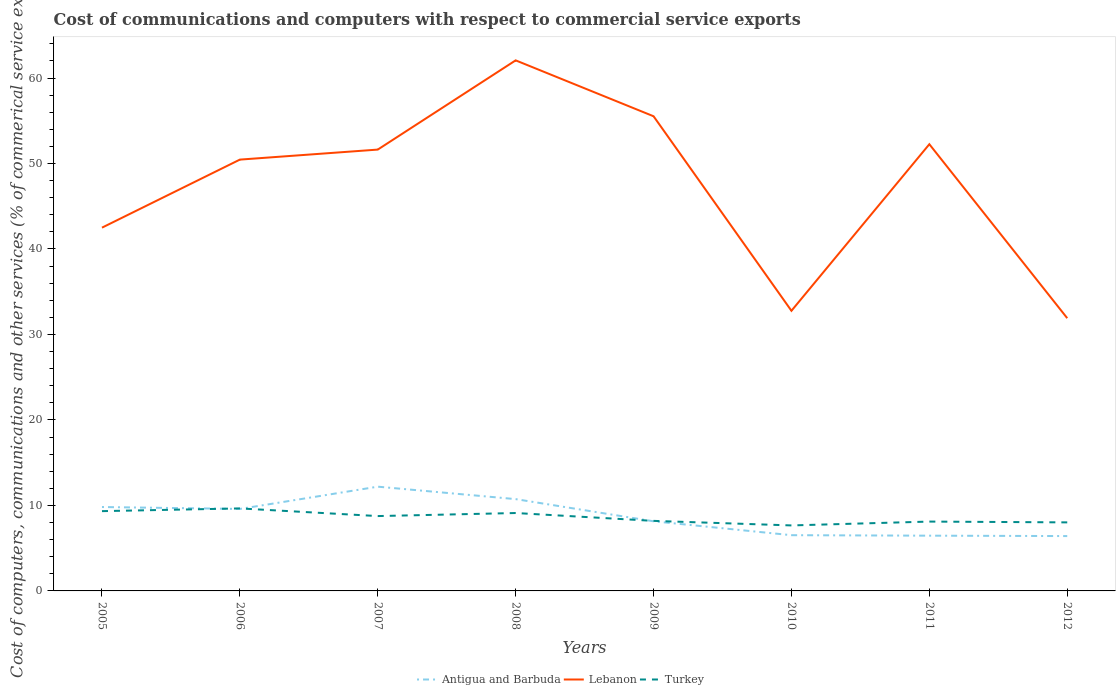How many different coloured lines are there?
Keep it short and to the point. 3. Across all years, what is the maximum cost of communications and computers in Antigua and Barbuda?
Ensure brevity in your answer.  6.42. In which year was the cost of communications and computers in Antigua and Barbuda maximum?
Offer a very short reply. 2012. What is the total cost of communications and computers in Antigua and Barbuda in the graph?
Your answer should be compact. 0.1. What is the difference between the highest and the second highest cost of communications and computers in Lebanon?
Keep it short and to the point. 30.16. Is the cost of communications and computers in Antigua and Barbuda strictly greater than the cost of communications and computers in Lebanon over the years?
Give a very brief answer. Yes. How many years are there in the graph?
Give a very brief answer. 8. Are the values on the major ticks of Y-axis written in scientific E-notation?
Offer a very short reply. No. Does the graph contain any zero values?
Offer a terse response. No. Does the graph contain grids?
Keep it short and to the point. No. How are the legend labels stacked?
Your response must be concise. Horizontal. What is the title of the graph?
Make the answer very short. Cost of communications and computers with respect to commercial service exports. Does "Seychelles" appear as one of the legend labels in the graph?
Offer a very short reply. No. What is the label or title of the X-axis?
Your answer should be very brief. Years. What is the label or title of the Y-axis?
Your answer should be very brief. Cost of computers, communications and other services (% of commerical service exports). What is the Cost of computers, communications and other services (% of commerical service exports) in Antigua and Barbuda in 2005?
Provide a succinct answer. 9.82. What is the Cost of computers, communications and other services (% of commerical service exports) in Lebanon in 2005?
Your answer should be very brief. 42.49. What is the Cost of computers, communications and other services (% of commerical service exports) in Turkey in 2005?
Provide a short and direct response. 9.33. What is the Cost of computers, communications and other services (% of commerical service exports) of Antigua and Barbuda in 2006?
Offer a very short reply. 9.59. What is the Cost of computers, communications and other services (% of commerical service exports) in Lebanon in 2006?
Offer a terse response. 50.46. What is the Cost of computers, communications and other services (% of commerical service exports) of Turkey in 2006?
Provide a short and direct response. 9.65. What is the Cost of computers, communications and other services (% of commerical service exports) in Antigua and Barbuda in 2007?
Keep it short and to the point. 12.2. What is the Cost of computers, communications and other services (% of commerical service exports) in Lebanon in 2007?
Keep it short and to the point. 51.63. What is the Cost of computers, communications and other services (% of commerical service exports) of Turkey in 2007?
Ensure brevity in your answer.  8.76. What is the Cost of computers, communications and other services (% of commerical service exports) of Antigua and Barbuda in 2008?
Your answer should be very brief. 10.74. What is the Cost of computers, communications and other services (% of commerical service exports) in Lebanon in 2008?
Offer a terse response. 62.07. What is the Cost of computers, communications and other services (% of commerical service exports) of Turkey in 2008?
Provide a succinct answer. 9.11. What is the Cost of computers, communications and other services (% of commerical service exports) in Antigua and Barbuda in 2009?
Offer a very short reply. 8.15. What is the Cost of computers, communications and other services (% of commerical service exports) in Lebanon in 2009?
Give a very brief answer. 55.53. What is the Cost of computers, communications and other services (% of commerical service exports) of Turkey in 2009?
Make the answer very short. 8.19. What is the Cost of computers, communications and other services (% of commerical service exports) in Antigua and Barbuda in 2010?
Provide a succinct answer. 6.52. What is the Cost of computers, communications and other services (% of commerical service exports) in Lebanon in 2010?
Offer a terse response. 32.77. What is the Cost of computers, communications and other services (% of commerical service exports) of Turkey in 2010?
Make the answer very short. 7.66. What is the Cost of computers, communications and other services (% of commerical service exports) in Antigua and Barbuda in 2011?
Provide a short and direct response. 6.46. What is the Cost of computers, communications and other services (% of commerical service exports) of Lebanon in 2011?
Ensure brevity in your answer.  52.26. What is the Cost of computers, communications and other services (% of commerical service exports) in Turkey in 2011?
Your response must be concise. 8.11. What is the Cost of computers, communications and other services (% of commerical service exports) of Antigua and Barbuda in 2012?
Offer a very short reply. 6.42. What is the Cost of computers, communications and other services (% of commerical service exports) of Lebanon in 2012?
Offer a terse response. 31.91. What is the Cost of computers, communications and other services (% of commerical service exports) of Turkey in 2012?
Your answer should be compact. 8.02. Across all years, what is the maximum Cost of computers, communications and other services (% of commerical service exports) of Antigua and Barbuda?
Your response must be concise. 12.2. Across all years, what is the maximum Cost of computers, communications and other services (% of commerical service exports) in Lebanon?
Offer a terse response. 62.07. Across all years, what is the maximum Cost of computers, communications and other services (% of commerical service exports) in Turkey?
Your response must be concise. 9.65. Across all years, what is the minimum Cost of computers, communications and other services (% of commerical service exports) of Antigua and Barbuda?
Provide a succinct answer. 6.42. Across all years, what is the minimum Cost of computers, communications and other services (% of commerical service exports) in Lebanon?
Your response must be concise. 31.91. Across all years, what is the minimum Cost of computers, communications and other services (% of commerical service exports) in Turkey?
Offer a terse response. 7.66. What is the total Cost of computers, communications and other services (% of commerical service exports) of Antigua and Barbuda in the graph?
Your response must be concise. 69.89. What is the total Cost of computers, communications and other services (% of commerical service exports) in Lebanon in the graph?
Your response must be concise. 379.11. What is the total Cost of computers, communications and other services (% of commerical service exports) in Turkey in the graph?
Provide a succinct answer. 68.84. What is the difference between the Cost of computers, communications and other services (% of commerical service exports) of Antigua and Barbuda in 2005 and that in 2006?
Provide a succinct answer. 0.23. What is the difference between the Cost of computers, communications and other services (% of commerical service exports) in Lebanon in 2005 and that in 2006?
Provide a succinct answer. -7.96. What is the difference between the Cost of computers, communications and other services (% of commerical service exports) in Turkey in 2005 and that in 2006?
Offer a terse response. -0.32. What is the difference between the Cost of computers, communications and other services (% of commerical service exports) in Antigua and Barbuda in 2005 and that in 2007?
Offer a very short reply. -2.38. What is the difference between the Cost of computers, communications and other services (% of commerical service exports) in Lebanon in 2005 and that in 2007?
Make the answer very short. -9.13. What is the difference between the Cost of computers, communications and other services (% of commerical service exports) of Turkey in 2005 and that in 2007?
Your answer should be compact. 0.58. What is the difference between the Cost of computers, communications and other services (% of commerical service exports) of Antigua and Barbuda in 2005 and that in 2008?
Provide a succinct answer. -0.92. What is the difference between the Cost of computers, communications and other services (% of commerical service exports) of Lebanon in 2005 and that in 2008?
Your answer should be compact. -19.57. What is the difference between the Cost of computers, communications and other services (% of commerical service exports) of Turkey in 2005 and that in 2008?
Make the answer very short. 0.22. What is the difference between the Cost of computers, communications and other services (% of commerical service exports) of Antigua and Barbuda in 2005 and that in 2009?
Your answer should be compact. 1.67. What is the difference between the Cost of computers, communications and other services (% of commerical service exports) of Lebanon in 2005 and that in 2009?
Offer a very short reply. -13.03. What is the difference between the Cost of computers, communications and other services (% of commerical service exports) in Turkey in 2005 and that in 2009?
Offer a very short reply. 1.14. What is the difference between the Cost of computers, communications and other services (% of commerical service exports) in Antigua and Barbuda in 2005 and that in 2010?
Your answer should be very brief. 3.29. What is the difference between the Cost of computers, communications and other services (% of commerical service exports) in Lebanon in 2005 and that in 2010?
Your answer should be compact. 9.72. What is the difference between the Cost of computers, communications and other services (% of commerical service exports) of Turkey in 2005 and that in 2010?
Offer a terse response. 1.67. What is the difference between the Cost of computers, communications and other services (% of commerical service exports) of Antigua and Barbuda in 2005 and that in 2011?
Provide a succinct answer. 3.35. What is the difference between the Cost of computers, communications and other services (% of commerical service exports) in Lebanon in 2005 and that in 2011?
Provide a short and direct response. -9.76. What is the difference between the Cost of computers, communications and other services (% of commerical service exports) in Turkey in 2005 and that in 2011?
Ensure brevity in your answer.  1.22. What is the difference between the Cost of computers, communications and other services (% of commerical service exports) of Antigua and Barbuda in 2005 and that in 2012?
Your answer should be very brief. 3.4. What is the difference between the Cost of computers, communications and other services (% of commerical service exports) of Lebanon in 2005 and that in 2012?
Your answer should be very brief. 10.59. What is the difference between the Cost of computers, communications and other services (% of commerical service exports) of Turkey in 2005 and that in 2012?
Offer a very short reply. 1.32. What is the difference between the Cost of computers, communications and other services (% of commerical service exports) of Antigua and Barbuda in 2006 and that in 2007?
Provide a short and direct response. -2.61. What is the difference between the Cost of computers, communications and other services (% of commerical service exports) in Lebanon in 2006 and that in 2007?
Provide a short and direct response. -1.17. What is the difference between the Cost of computers, communications and other services (% of commerical service exports) of Turkey in 2006 and that in 2007?
Provide a succinct answer. 0.9. What is the difference between the Cost of computers, communications and other services (% of commerical service exports) in Antigua and Barbuda in 2006 and that in 2008?
Ensure brevity in your answer.  -1.15. What is the difference between the Cost of computers, communications and other services (% of commerical service exports) of Lebanon in 2006 and that in 2008?
Your answer should be very brief. -11.61. What is the difference between the Cost of computers, communications and other services (% of commerical service exports) in Turkey in 2006 and that in 2008?
Keep it short and to the point. 0.54. What is the difference between the Cost of computers, communications and other services (% of commerical service exports) of Antigua and Barbuda in 2006 and that in 2009?
Ensure brevity in your answer.  1.44. What is the difference between the Cost of computers, communications and other services (% of commerical service exports) in Lebanon in 2006 and that in 2009?
Make the answer very short. -5.07. What is the difference between the Cost of computers, communications and other services (% of commerical service exports) of Turkey in 2006 and that in 2009?
Offer a very short reply. 1.46. What is the difference between the Cost of computers, communications and other services (% of commerical service exports) in Antigua and Barbuda in 2006 and that in 2010?
Give a very brief answer. 3.07. What is the difference between the Cost of computers, communications and other services (% of commerical service exports) in Lebanon in 2006 and that in 2010?
Keep it short and to the point. 17.68. What is the difference between the Cost of computers, communications and other services (% of commerical service exports) in Turkey in 2006 and that in 2010?
Provide a succinct answer. 1.99. What is the difference between the Cost of computers, communications and other services (% of commerical service exports) of Antigua and Barbuda in 2006 and that in 2011?
Your response must be concise. 3.13. What is the difference between the Cost of computers, communications and other services (% of commerical service exports) of Lebanon in 2006 and that in 2011?
Provide a succinct answer. -1.8. What is the difference between the Cost of computers, communications and other services (% of commerical service exports) in Turkey in 2006 and that in 2011?
Provide a succinct answer. 1.54. What is the difference between the Cost of computers, communications and other services (% of commerical service exports) of Antigua and Barbuda in 2006 and that in 2012?
Your response must be concise. 3.17. What is the difference between the Cost of computers, communications and other services (% of commerical service exports) of Lebanon in 2006 and that in 2012?
Give a very brief answer. 18.55. What is the difference between the Cost of computers, communications and other services (% of commerical service exports) of Turkey in 2006 and that in 2012?
Provide a short and direct response. 1.63. What is the difference between the Cost of computers, communications and other services (% of commerical service exports) in Antigua and Barbuda in 2007 and that in 2008?
Offer a terse response. 1.46. What is the difference between the Cost of computers, communications and other services (% of commerical service exports) of Lebanon in 2007 and that in 2008?
Offer a very short reply. -10.44. What is the difference between the Cost of computers, communications and other services (% of commerical service exports) of Turkey in 2007 and that in 2008?
Your response must be concise. -0.36. What is the difference between the Cost of computers, communications and other services (% of commerical service exports) of Antigua and Barbuda in 2007 and that in 2009?
Give a very brief answer. 4.05. What is the difference between the Cost of computers, communications and other services (% of commerical service exports) in Lebanon in 2007 and that in 2009?
Give a very brief answer. -3.9. What is the difference between the Cost of computers, communications and other services (% of commerical service exports) of Turkey in 2007 and that in 2009?
Keep it short and to the point. 0.56. What is the difference between the Cost of computers, communications and other services (% of commerical service exports) of Antigua and Barbuda in 2007 and that in 2010?
Offer a very short reply. 5.68. What is the difference between the Cost of computers, communications and other services (% of commerical service exports) in Lebanon in 2007 and that in 2010?
Your answer should be compact. 18.86. What is the difference between the Cost of computers, communications and other services (% of commerical service exports) of Turkey in 2007 and that in 2010?
Keep it short and to the point. 1.09. What is the difference between the Cost of computers, communications and other services (% of commerical service exports) in Antigua and Barbuda in 2007 and that in 2011?
Ensure brevity in your answer.  5.73. What is the difference between the Cost of computers, communications and other services (% of commerical service exports) in Lebanon in 2007 and that in 2011?
Your answer should be compact. -0.63. What is the difference between the Cost of computers, communications and other services (% of commerical service exports) in Turkey in 2007 and that in 2011?
Provide a succinct answer. 0.64. What is the difference between the Cost of computers, communications and other services (% of commerical service exports) of Antigua and Barbuda in 2007 and that in 2012?
Provide a succinct answer. 5.78. What is the difference between the Cost of computers, communications and other services (% of commerical service exports) in Lebanon in 2007 and that in 2012?
Give a very brief answer. 19.72. What is the difference between the Cost of computers, communications and other services (% of commerical service exports) of Turkey in 2007 and that in 2012?
Offer a terse response. 0.74. What is the difference between the Cost of computers, communications and other services (% of commerical service exports) in Antigua and Barbuda in 2008 and that in 2009?
Offer a very short reply. 2.59. What is the difference between the Cost of computers, communications and other services (% of commerical service exports) of Lebanon in 2008 and that in 2009?
Keep it short and to the point. 6.54. What is the difference between the Cost of computers, communications and other services (% of commerical service exports) in Turkey in 2008 and that in 2009?
Offer a terse response. 0.92. What is the difference between the Cost of computers, communications and other services (% of commerical service exports) in Antigua and Barbuda in 2008 and that in 2010?
Offer a terse response. 4.22. What is the difference between the Cost of computers, communications and other services (% of commerical service exports) in Lebanon in 2008 and that in 2010?
Provide a succinct answer. 29.29. What is the difference between the Cost of computers, communications and other services (% of commerical service exports) in Turkey in 2008 and that in 2010?
Keep it short and to the point. 1.45. What is the difference between the Cost of computers, communications and other services (% of commerical service exports) of Antigua and Barbuda in 2008 and that in 2011?
Give a very brief answer. 4.28. What is the difference between the Cost of computers, communications and other services (% of commerical service exports) in Lebanon in 2008 and that in 2011?
Your answer should be compact. 9.81. What is the difference between the Cost of computers, communications and other services (% of commerical service exports) of Turkey in 2008 and that in 2011?
Keep it short and to the point. 1. What is the difference between the Cost of computers, communications and other services (% of commerical service exports) in Antigua and Barbuda in 2008 and that in 2012?
Your answer should be very brief. 4.32. What is the difference between the Cost of computers, communications and other services (% of commerical service exports) in Lebanon in 2008 and that in 2012?
Provide a succinct answer. 30.16. What is the difference between the Cost of computers, communications and other services (% of commerical service exports) of Turkey in 2008 and that in 2012?
Make the answer very short. 1.1. What is the difference between the Cost of computers, communications and other services (% of commerical service exports) in Antigua and Barbuda in 2009 and that in 2010?
Your response must be concise. 1.63. What is the difference between the Cost of computers, communications and other services (% of commerical service exports) of Lebanon in 2009 and that in 2010?
Provide a short and direct response. 22.76. What is the difference between the Cost of computers, communications and other services (% of commerical service exports) in Turkey in 2009 and that in 2010?
Make the answer very short. 0.53. What is the difference between the Cost of computers, communications and other services (% of commerical service exports) in Antigua and Barbuda in 2009 and that in 2011?
Offer a very short reply. 1.68. What is the difference between the Cost of computers, communications and other services (% of commerical service exports) of Lebanon in 2009 and that in 2011?
Provide a short and direct response. 3.27. What is the difference between the Cost of computers, communications and other services (% of commerical service exports) of Turkey in 2009 and that in 2011?
Offer a terse response. 0.08. What is the difference between the Cost of computers, communications and other services (% of commerical service exports) in Antigua and Barbuda in 2009 and that in 2012?
Provide a succinct answer. 1.73. What is the difference between the Cost of computers, communications and other services (% of commerical service exports) in Lebanon in 2009 and that in 2012?
Ensure brevity in your answer.  23.62. What is the difference between the Cost of computers, communications and other services (% of commerical service exports) in Turkey in 2009 and that in 2012?
Make the answer very short. 0.18. What is the difference between the Cost of computers, communications and other services (% of commerical service exports) of Antigua and Barbuda in 2010 and that in 2011?
Your response must be concise. 0.06. What is the difference between the Cost of computers, communications and other services (% of commerical service exports) in Lebanon in 2010 and that in 2011?
Offer a very short reply. -19.48. What is the difference between the Cost of computers, communications and other services (% of commerical service exports) in Turkey in 2010 and that in 2011?
Your response must be concise. -0.45. What is the difference between the Cost of computers, communications and other services (% of commerical service exports) in Antigua and Barbuda in 2010 and that in 2012?
Your answer should be very brief. 0.1. What is the difference between the Cost of computers, communications and other services (% of commerical service exports) of Lebanon in 2010 and that in 2012?
Give a very brief answer. 0.87. What is the difference between the Cost of computers, communications and other services (% of commerical service exports) of Turkey in 2010 and that in 2012?
Give a very brief answer. -0.36. What is the difference between the Cost of computers, communications and other services (% of commerical service exports) in Antigua and Barbuda in 2011 and that in 2012?
Your response must be concise. 0.05. What is the difference between the Cost of computers, communications and other services (% of commerical service exports) in Lebanon in 2011 and that in 2012?
Offer a terse response. 20.35. What is the difference between the Cost of computers, communications and other services (% of commerical service exports) in Turkey in 2011 and that in 2012?
Your response must be concise. 0.09. What is the difference between the Cost of computers, communications and other services (% of commerical service exports) in Antigua and Barbuda in 2005 and the Cost of computers, communications and other services (% of commerical service exports) in Lebanon in 2006?
Offer a terse response. -40.64. What is the difference between the Cost of computers, communications and other services (% of commerical service exports) in Antigua and Barbuda in 2005 and the Cost of computers, communications and other services (% of commerical service exports) in Turkey in 2006?
Ensure brevity in your answer.  0.16. What is the difference between the Cost of computers, communications and other services (% of commerical service exports) of Lebanon in 2005 and the Cost of computers, communications and other services (% of commerical service exports) of Turkey in 2006?
Your answer should be very brief. 32.84. What is the difference between the Cost of computers, communications and other services (% of commerical service exports) of Antigua and Barbuda in 2005 and the Cost of computers, communications and other services (% of commerical service exports) of Lebanon in 2007?
Keep it short and to the point. -41.81. What is the difference between the Cost of computers, communications and other services (% of commerical service exports) of Antigua and Barbuda in 2005 and the Cost of computers, communications and other services (% of commerical service exports) of Turkey in 2007?
Keep it short and to the point. 1.06. What is the difference between the Cost of computers, communications and other services (% of commerical service exports) of Lebanon in 2005 and the Cost of computers, communications and other services (% of commerical service exports) of Turkey in 2007?
Offer a terse response. 33.74. What is the difference between the Cost of computers, communications and other services (% of commerical service exports) in Antigua and Barbuda in 2005 and the Cost of computers, communications and other services (% of commerical service exports) in Lebanon in 2008?
Offer a terse response. -52.25. What is the difference between the Cost of computers, communications and other services (% of commerical service exports) of Antigua and Barbuda in 2005 and the Cost of computers, communications and other services (% of commerical service exports) of Turkey in 2008?
Ensure brevity in your answer.  0.7. What is the difference between the Cost of computers, communications and other services (% of commerical service exports) in Lebanon in 2005 and the Cost of computers, communications and other services (% of commerical service exports) in Turkey in 2008?
Make the answer very short. 33.38. What is the difference between the Cost of computers, communications and other services (% of commerical service exports) in Antigua and Barbuda in 2005 and the Cost of computers, communications and other services (% of commerical service exports) in Lebanon in 2009?
Provide a short and direct response. -45.71. What is the difference between the Cost of computers, communications and other services (% of commerical service exports) of Antigua and Barbuda in 2005 and the Cost of computers, communications and other services (% of commerical service exports) of Turkey in 2009?
Your response must be concise. 1.62. What is the difference between the Cost of computers, communications and other services (% of commerical service exports) in Lebanon in 2005 and the Cost of computers, communications and other services (% of commerical service exports) in Turkey in 2009?
Your answer should be very brief. 34.3. What is the difference between the Cost of computers, communications and other services (% of commerical service exports) in Antigua and Barbuda in 2005 and the Cost of computers, communications and other services (% of commerical service exports) in Lebanon in 2010?
Keep it short and to the point. -22.96. What is the difference between the Cost of computers, communications and other services (% of commerical service exports) in Antigua and Barbuda in 2005 and the Cost of computers, communications and other services (% of commerical service exports) in Turkey in 2010?
Provide a succinct answer. 2.15. What is the difference between the Cost of computers, communications and other services (% of commerical service exports) in Lebanon in 2005 and the Cost of computers, communications and other services (% of commerical service exports) in Turkey in 2010?
Make the answer very short. 34.83. What is the difference between the Cost of computers, communications and other services (% of commerical service exports) in Antigua and Barbuda in 2005 and the Cost of computers, communications and other services (% of commerical service exports) in Lebanon in 2011?
Provide a short and direct response. -42.44. What is the difference between the Cost of computers, communications and other services (% of commerical service exports) of Antigua and Barbuda in 2005 and the Cost of computers, communications and other services (% of commerical service exports) of Turkey in 2011?
Offer a very short reply. 1.7. What is the difference between the Cost of computers, communications and other services (% of commerical service exports) of Lebanon in 2005 and the Cost of computers, communications and other services (% of commerical service exports) of Turkey in 2011?
Provide a short and direct response. 34.38. What is the difference between the Cost of computers, communications and other services (% of commerical service exports) in Antigua and Barbuda in 2005 and the Cost of computers, communications and other services (% of commerical service exports) in Lebanon in 2012?
Make the answer very short. -22.09. What is the difference between the Cost of computers, communications and other services (% of commerical service exports) of Antigua and Barbuda in 2005 and the Cost of computers, communications and other services (% of commerical service exports) of Turkey in 2012?
Provide a short and direct response. 1.8. What is the difference between the Cost of computers, communications and other services (% of commerical service exports) of Lebanon in 2005 and the Cost of computers, communications and other services (% of commerical service exports) of Turkey in 2012?
Offer a very short reply. 34.48. What is the difference between the Cost of computers, communications and other services (% of commerical service exports) in Antigua and Barbuda in 2006 and the Cost of computers, communications and other services (% of commerical service exports) in Lebanon in 2007?
Provide a succinct answer. -42.04. What is the difference between the Cost of computers, communications and other services (% of commerical service exports) in Antigua and Barbuda in 2006 and the Cost of computers, communications and other services (% of commerical service exports) in Turkey in 2007?
Keep it short and to the point. 0.83. What is the difference between the Cost of computers, communications and other services (% of commerical service exports) of Lebanon in 2006 and the Cost of computers, communications and other services (% of commerical service exports) of Turkey in 2007?
Offer a terse response. 41.7. What is the difference between the Cost of computers, communications and other services (% of commerical service exports) in Antigua and Barbuda in 2006 and the Cost of computers, communications and other services (% of commerical service exports) in Lebanon in 2008?
Provide a short and direct response. -52.48. What is the difference between the Cost of computers, communications and other services (% of commerical service exports) in Antigua and Barbuda in 2006 and the Cost of computers, communications and other services (% of commerical service exports) in Turkey in 2008?
Offer a very short reply. 0.48. What is the difference between the Cost of computers, communications and other services (% of commerical service exports) of Lebanon in 2006 and the Cost of computers, communications and other services (% of commerical service exports) of Turkey in 2008?
Provide a short and direct response. 41.34. What is the difference between the Cost of computers, communications and other services (% of commerical service exports) in Antigua and Barbuda in 2006 and the Cost of computers, communications and other services (% of commerical service exports) in Lebanon in 2009?
Make the answer very short. -45.94. What is the difference between the Cost of computers, communications and other services (% of commerical service exports) in Antigua and Barbuda in 2006 and the Cost of computers, communications and other services (% of commerical service exports) in Turkey in 2009?
Your response must be concise. 1.4. What is the difference between the Cost of computers, communications and other services (% of commerical service exports) in Lebanon in 2006 and the Cost of computers, communications and other services (% of commerical service exports) in Turkey in 2009?
Provide a succinct answer. 42.26. What is the difference between the Cost of computers, communications and other services (% of commerical service exports) in Antigua and Barbuda in 2006 and the Cost of computers, communications and other services (% of commerical service exports) in Lebanon in 2010?
Your answer should be compact. -23.18. What is the difference between the Cost of computers, communications and other services (% of commerical service exports) of Antigua and Barbuda in 2006 and the Cost of computers, communications and other services (% of commerical service exports) of Turkey in 2010?
Your answer should be compact. 1.93. What is the difference between the Cost of computers, communications and other services (% of commerical service exports) in Lebanon in 2006 and the Cost of computers, communications and other services (% of commerical service exports) in Turkey in 2010?
Your answer should be compact. 42.79. What is the difference between the Cost of computers, communications and other services (% of commerical service exports) of Antigua and Barbuda in 2006 and the Cost of computers, communications and other services (% of commerical service exports) of Lebanon in 2011?
Offer a very short reply. -42.67. What is the difference between the Cost of computers, communications and other services (% of commerical service exports) in Antigua and Barbuda in 2006 and the Cost of computers, communications and other services (% of commerical service exports) in Turkey in 2011?
Make the answer very short. 1.48. What is the difference between the Cost of computers, communications and other services (% of commerical service exports) in Lebanon in 2006 and the Cost of computers, communications and other services (% of commerical service exports) in Turkey in 2011?
Make the answer very short. 42.34. What is the difference between the Cost of computers, communications and other services (% of commerical service exports) in Antigua and Barbuda in 2006 and the Cost of computers, communications and other services (% of commerical service exports) in Lebanon in 2012?
Provide a short and direct response. -22.32. What is the difference between the Cost of computers, communications and other services (% of commerical service exports) in Antigua and Barbuda in 2006 and the Cost of computers, communications and other services (% of commerical service exports) in Turkey in 2012?
Provide a short and direct response. 1.57. What is the difference between the Cost of computers, communications and other services (% of commerical service exports) in Lebanon in 2006 and the Cost of computers, communications and other services (% of commerical service exports) in Turkey in 2012?
Offer a very short reply. 42.44. What is the difference between the Cost of computers, communications and other services (% of commerical service exports) in Antigua and Barbuda in 2007 and the Cost of computers, communications and other services (% of commerical service exports) in Lebanon in 2008?
Offer a very short reply. -49.87. What is the difference between the Cost of computers, communications and other services (% of commerical service exports) of Antigua and Barbuda in 2007 and the Cost of computers, communications and other services (% of commerical service exports) of Turkey in 2008?
Give a very brief answer. 3.08. What is the difference between the Cost of computers, communications and other services (% of commerical service exports) of Lebanon in 2007 and the Cost of computers, communications and other services (% of commerical service exports) of Turkey in 2008?
Ensure brevity in your answer.  42.52. What is the difference between the Cost of computers, communications and other services (% of commerical service exports) of Antigua and Barbuda in 2007 and the Cost of computers, communications and other services (% of commerical service exports) of Lebanon in 2009?
Give a very brief answer. -43.33. What is the difference between the Cost of computers, communications and other services (% of commerical service exports) of Antigua and Barbuda in 2007 and the Cost of computers, communications and other services (% of commerical service exports) of Turkey in 2009?
Your answer should be very brief. 4. What is the difference between the Cost of computers, communications and other services (% of commerical service exports) in Lebanon in 2007 and the Cost of computers, communications and other services (% of commerical service exports) in Turkey in 2009?
Your answer should be very brief. 43.44. What is the difference between the Cost of computers, communications and other services (% of commerical service exports) of Antigua and Barbuda in 2007 and the Cost of computers, communications and other services (% of commerical service exports) of Lebanon in 2010?
Your answer should be compact. -20.58. What is the difference between the Cost of computers, communications and other services (% of commerical service exports) in Antigua and Barbuda in 2007 and the Cost of computers, communications and other services (% of commerical service exports) in Turkey in 2010?
Provide a succinct answer. 4.53. What is the difference between the Cost of computers, communications and other services (% of commerical service exports) in Lebanon in 2007 and the Cost of computers, communications and other services (% of commerical service exports) in Turkey in 2010?
Your answer should be very brief. 43.97. What is the difference between the Cost of computers, communications and other services (% of commerical service exports) in Antigua and Barbuda in 2007 and the Cost of computers, communications and other services (% of commerical service exports) in Lebanon in 2011?
Make the answer very short. -40.06. What is the difference between the Cost of computers, communications and other services (% of commerical service exports) in Antigua and Barbuda in 2007 and the Cost of computers, communications and other services (% of commerical service exports) in Turkey in 2011?
Your answer should be compact. 4.08. What is the difference between the Cost of computers, communications and other services (% of commerical service exports) in Lebanon in 2007 and the Cost of computers, communications and other services (% of commerical service exports) in Turkey in 2011?
Ensure brevity in your answer.  43.52. What is the difference between the Cost of computers, communications and other services (% of commerical service exports) in Antigua and Barbuda in 2007 and the Cost of computers, communications and other services (% of commerical service exports) in Lebanon in 2012?
Offer a very short reply. -19.71. What is the difference between the Cost of computers, communications and other services (% of commerical service exports) in Antigua and Barbuda in 2007 and the Cost of computers, communications and other services (% of commerical service exports) in Turkey in 2012?
Give a very brief answer. 4.18. What is the difference between the Cost of computers, communications and other services (% of commerical service exports) in Lebanon in 2007 and the Cost of computers, communications and other services (% of commerical service exports) in Turkey in 2012?
Offer a very short reply. 43.61. What is the difference between the Cost of computers, communications and other services (% of commerical service exports) in Antigua and Barbuda in 2008 and the Cost of computers, communications and other services (% of commerical service exports) in Lebanon in 2009?
Your answer should be compact. -44.79. What is the difference between the Cost of computers, communications and other services (% of commerical service exports) of Antigua and Barbuda in 2008 and the Cost of computers, communications and other services (% of commerical service exports) of Turkey in 2009?
Give a very brief answer. 2.55. What is the difference between the Cost of computers, communications and other services (% of commerical service exports) of Lebanon in 2008 and the Cost of computers, communications and other services (% of commerical service exports) of Turkey in 2009?
Your answer should be compact. 53.87. What is the difference between the Cost of computers, communications and other services (% of commerical service exports) of Antigua and Barbuda in 2008 and the Cost of computers, communications and other services (% of commerical service exports) of Lebanon in 2010?
Your answer should be compact. -22.03. What is the difference between the Cost of computers, communications and other services (% of commerical service exports) in Antigua and Barbuda in 2008 and the Cost of computers, communications and other services (% of commerical service exports) in Turkey in 2010?
Your answer should be compact. 3.08. What is the difference between the Cost of computers, communications and other services (% of commerical service exports) of Lebanon in 2008 and the Cost of computers, communications and other services (% of commerical service exports) of Turkey in 2010?
Ensure brevity in your answer.  54.41. What is the difference between the Cost of computers, communications and other services (% of commerical service exports) in Antigua and Barbuda in 2008 and the Cost of computers, communications and other services (% of commerical service exports) in Lebanon in 2011?
Give a very brief answer. -41.52. What is the difference between the Cost of computers, communications and other services (% of commerical service exports) of Antigua and Barbuda in 2008 and the Cost of computers, communications and other services (% of commerical service exports) of Turkey in 2011?
Provide a short and direct response. 2.63. What is the difference between the Cost of computers, communications and other services (% of commerical service exports) of Lebanon in 2008 and the Cost of computers, communications and other services (% of commerical service exports) of Turkey in 2011?
Provide a succinct answer. 53.96. What is the difference between the Cost of computers, communications and other services (% of commerical service exports) of Antigua and Barbuda in 2008 and the Cost of computers, communications and other services (% of commerical service exports) of Lebanon in 2012?
Provide a short and direct response. -21.17. What is the difference between the Cost of computers, communications and other services (% of commerical service exports) of Antigua and Barbuda in 2008 and the Cost of computers, communications and other services (% of commerical service exports) of Turkey in 2012?
Make the answer very short. 2.72. What is the difference between the Cost of computers, communications and other services (% of commerical service exports) in Lebanon in 2008 and the Cost of computers, communications and other services (% of commerical service exports) in Turkey in 2012?
Provide a succinct answer. 54.05. What is the difference between the Cost of computers, communications and other services (% of commerical service exports) of Antigua and Barbuda in 2009 and the Cost of computers, communications and other services (% of commerical service exports) of Lebanon in 2010?
Ensure brevity in your answer.  -24.63. What is the difference between the Cost of computers, communications and other services (% of commerical service exports) of Antigua and Barbuda in 2009 and the Cost of computers, communications and other services (% of commerical service exports) of Turkey in 2010?
Keep it short and to the point. 0.48. What is the difference between the Cost of computers, communications and other services (% of commerical service exports) in Lebanon in 2009 and the Cost of computers, communications and other services (% of commerical service exports) in Turkey in 2010?
Ensure brevity in your answer.  47.87. What is the difference between the Cost of computers, communications and other services (% of commerical service exports) of Antigua and Barbuda in 2009 and the Cost of computers, communications and other services (% of commerical service exports) of Lebanon in 2011?
Make the answer very short. -44.11. What is the difference between the Cost of computers, communications and other services (% of commerical service exports) of Antigua and Barbuda in 2009 and the Cost of computers, communications and other services (% of commerical service exports) of Turkey in 2011?
Provide a succinct answer. 0.03. What is the difference between the Cost of computers, communications and other services (% of commerical service exports) in Lebanon in 2009 and the Cost of computers, communications and other services (% of commerical service exports) in Turkey in 2011?
Your response must be concise. 47.42. What is the difference between the Cost of computers, communications and other services (% of commerical service exports) in Antigua and Barbuda in 2009 and the Cost of computers, communications and other services (% of commerical service exports) in Lebanon in 2012?
Make the answer very short. -23.76. What is the difference between the Cost of computers, communications and other services (% of commerical service exports) in Antigua and Barbuda in 2009 and the Cost of computers, communications and other services (% of commerical service exports) in Turkey in 2012?
Your response must be concise. 0.13. What is the difference between the Cost of computers, communications and other services (% of commerical service exports) of Lebanon in 2009 and the Cost of computers, communications and other services (% of commerical service exports) of Turkey in 2012?
Offer a terse response. 47.51. What is the difference between the Cost of computers, communications and other services (% of commerical service exports) of Antigua and Barbuda in 2010 and the Cost of computers, communications and other services (% of commerical service exports) of Lebanon in 2011?
Ensure brevity in your answer.  -45.74. What is the difference between the Cost of computers, communications and other services (% of commerical service exports) in Antigua and Barbuda in 2010 and the Cost of computers, communications and other services (% of commerical service exports) in Turkey in 2011?
Provide a succinct answer. -1.59. What is the difference between the Cost of computers, communications and other services (% of commerical service exports) in Lebanon in 2010 and the Cost of computers, communications and other services (% of commerical service exports) in Turkey in 2011?
Provide a succinct answer. 24.66. What is the difference between the Cost of computers, communications and other services (% of commerical service exports) of Antigua and Barbuda in 2010 and the Cost of computers, communications and other services (% of commerical service exports) of Lebanon in 2012?
Provide a short and direct response. -25.39. What is the difference between the Cost of computers, communications and other services (% of commerical service exports) of Antigua and Barbuda in 2010 and the Cost of computers, communications and other services (% of commerical service exports) of Turkey in 2012?
Make the answer very short. -1.5. What is the difference between the Cost of computers, communications and other services (% of commerical service exports) in Lebanon in 2010 and the Cost of computers, communications and other services (% of commerical service exports) in Turkey in 2012?
Provide a short and direct response. 24.75. What is the difference between the Cost of computers, communications and other services (% of commerical service exports) of Antigua and Barbuda in 2011 and the Cost of computers, communications and other services (% of commerical service exports) of Lebanon in 2012?
Offer a very short reply. -25.44. What is the difference between the Cost of computers, communications and other services (% of commerical service exports) of Antigua and Barbuda in 2011 and the Cost of computers, communications and other services (% of commerical service exports) of Turkey in 2012?
Your response must be concise. -1.56. What is the difference between the Cost of computers, communications and other services (% of commerical service exports) in Lebanon in 2011 and the Cost of computers, communications and other services (% of commerical service exports) in Turkey in 2012?
Give a very brief answer. 44.24. What is the average Cost of computers, communications and other services (% of commerical service exports) in Antigua and Barbuda per year?
Give a very brief answer. 8.74. What is the average Cost of computers, communications and other services (% of commerical service exports) of Lebanon per year?
Your response must be concise. 47.39. What is the average Cost of computers, communications and other services (% of commerical service exports) of Turkey per year?
Keep it short and to the point. 8.61. In the year 2005, what is the difference between the Cost of computers, communications and other services (% of commerical service exports) of Antigua and Barbuda and Cost of computers, communications and other services (% of commerical service exports) of Lebanon?
Offer a terse response. -32.68. In the year 2005, what is the difference between the Cost of computers, communications and other services (% of commerical service exports) in Antigua and Barbuda and Cost of computers, communications and other services (% of commerical service exports) in Turkey?
Your answer should be compact. 0.48. In the year 2005, what is the difference between the Cost of computers, communications and other services (% of commerical service exports) in Lebanon and Cost of computers, communications and other services (% of commerical service exports) in Turkey?
Provide a short and direct response. 33.16. In the year 2006, what is the difference between the Cost of computers, communications and other services (% of commerical service exports) in Antigua and Barbuda and Cost of computers, communications and other services (% of commerical service exports) in Lebanon?
Provide a succinct answer. -40.87. In the year 2006, what is the difference between the Cost of computers, communications and other services (% of commerical service exports) in Antigua and Barbuda and Cost of computers, communications and other services (% of commerical service exports) in Turkey?
Provide a short and direct response. -0.06. In the year 2006, what is the difference between the Cost of computers, communications and other services (% of commerical service exports) of Lebanon and Cost of computers, communications and other services (% of commerical service exports) of Turkey?
Offer a very short reply. 40.8. In the year 2007, what is the difference between the Cost of computers, communications and other services (% of commerical service exports) of Antigua and Barbuda and Cost of computers, communications and other services (% of commerical service exports) of Lebanon?
Give a very brief answer. -39.43. In the year 2007, what is the difference between the Cost of computers, communications and other services (% of commerical service exports) of Antigua and Barbuda and Cost of computers, communications and other services (% of commerical service exports) of Turkey?
Offer a very short reply. 3.44. In the year 2007, what is the difference between the Cost of computers, communications and other services (% of commerical service exports) of Lebanon and Cost of computers, communications and other services (% of commerical service exports) of Turkey?
Your answer should be compact. 42.87. In the year 2008, what is the difference between the Cost of computers, communications and other services (% of commerical service exports) in Antigua and Barbuda and Cost of computers, communications and other services (% of commerical service exports) in Lebanon?
Provide a succinct answer. -51.33. In the year 2008, what is the difference between the Cost of computers, communications and other services (% of commerical service exports) of Antigua and Barbuda and Cost of computers, communications and other services (% of commerical service exports) of Turkey?
Ensure brevity in your answer.  1.63. In the year 2008, what is the difference between the Cost of computers, communications and other services (% of commerical service exports) of Lebanon and Cost of computers, communications and other services (% of commerical service exports) of Turkey?
Provide a short and direct response. 52.95. In the year 2009, what is the difference between the Cost of computers, communications and other services (% of commerical service exports) in Antigua and Barbuda and Cost of computers, communications and other services (% of commerical service exports) in Lebanon?
Provide a short and direct response. -47.38. In the year 2009, what is the difference between the Cost of computers, communications and other services (% of commerical service exports) in Antigua and Barbuda and Cost of computers, communications and other services (% of commerical service exports) in Turkey?
Your answer should be compact. -0.05. In the year 2009, what is the difference between the Cost of computers, communications and other services (% of commerical service exports) of Lebanon and Cost of computers, communications and other services (% of commerical service exports) of Turkey?
Ensure brevity in your answer.  47.33. In the year 2010, what is the difference between the Cost of computers, communications and other services (% of commerical service exports) of Antigua and Barbuda and Cost of computers, communications and other services (% of commerical service exports) of Lebanon?
Your response must be concise. -26.25. In the year 2010, what is the difference between the Cost of computers, communications and other services (% of commerical service exports) of Antigua and Barbuda and Cost of computers, communications and other services (% of commerical service exports) of Turkey?
Your response must be concise. -1.14. In the year 2010, what is the difference between the Cost of computers, communications and other services (% of commerical service exports) in Lebanon and Cost of computers, communications and other services (% of commerical service exports) in Turkey?
Your answer should be compact. 25.11. In the year 2011, what is the difference between the Cost of computers, communications and other services (% of commerical service exports) of Antigua and Barbuda and Cost of computers, communications and other services (% of commerical service exports) of Lebanon?
Provide a short and direct response. -45.79. In the year 2011, what is the difference between the Cost of computers, communications and other services (% of commerical service exports) in Antigua and Barbuda and Cost of computers, communications and other services (% of commerical service exports) in Turkey?
Your response must be concise. -1.65. In the year 2011, what is the difference between the Cost of computers, communications and other services (% of commerical service exports) in Lebanon and Cost of computers, communications and other services (% of commerical service exports) in Turkey?
Offer a terse response. 44.14. In the year 2012, what is the difference between the Cost of computers, communications and other services (% of commerical service exports) in Antigua and Barbuda and Cost of computers, communications and other services (% of commerical service exports) in Lebanon?
Offer a terse response. -25.49. In the year 2012, what is the difference between the Cost of computers, communications and other services (% of commerical service exports) in Antigua and Barbuda and Cost of computers, communications and other services (% of commerical service exports) in Turkey?
Provide a succinct answer. -1.6. In the year 2012, what is the difference between the Cost of computers, communications and other services (% of commerical service exports) of Lebanon and Cost of computers, communications and other services (% of commerical service exports) of Turkey?
Provide a short and direct response. 23.89. What is the ratio of the Cost of computers, communications and other services (% of commerical service exports) in Antigua and Barbuda in 2005 to that in 2006?
Provide a short and direct response. 1.02. What is the ratio of the Cost of computers, communications and other services (% of commerical service exports) in Lebanon in 2005 to that in 2006?
Provide a succinct answer. 0.84. What is the ratio of the Cost of computers, communications and other services (% of commerical service exports) of Turkey in 2005 to that in 2006?
Provide a succinct answer. 0.97. What is the ratio of the Cost of computers, communications and other services (% of commerical service exports) of Antigua and Barbuda in 2005 to that in 2007?
Provide a succinct answer. 0.8. What is the ratio of the Cost of computers, communications and other services (% of commerical service exports) in Lebanon in 2005 to that in 2007?
Offer a very short reply. 0.82. What is the ratio of the Cost of computers, communications and other services (% of commerical service exports) of Turkey in 2005 to that in 2007?
Your answer should be compact. 1.07. What is the ratio of the Cost of computers, communications and other services (% of commerical service exports) in Antigua and Barbuda in 2005 to that in 2008?
Provide a succinct answer. 0.91. What is the ratio of the Cost of computers, communications and other services (% of commerical service exports) of Lebanon in 2005 to that in 2008?
Ensure brevity in your answer.  0.68. What is the ratio of the Cost of computers, communications and other services (% of commerical service exports) in Turkey in 2005 to that in 2008?
Your answer should be very brief. 1.02. What is the ratio of the Cost of computers, communications and other services (% of commerical service exports) of Antigua and Barbuda in 2005 to that in 2009?
Ensure brevity in your answer.  1.21. What is the ratio of the Cost of computers, communications and other services (% of commerical service exports) in Lebanon in 2005 to that in 2009?
Your answer should be compact. 0.77. What is the ratio of the Cost of computers, communications and other services (% of commerical service exports) in Turkey in 2005 to that in 2009?
Offer a very short reply. 1.14. What is the ratio of the Cost of computers, communications and other services (% of commerical service exports) in Antigua and Barbuda in 2005 to that in 2010?
Offer a terse response. 1.51. What is the ratio of the Cost of computers, communications and other services (% of commerical service exports) of Lebanon in 2005 to that in 2010?
Ensure brevity in your answer.  1.3. What is the ratio of the Cost of computers, communications and other services (% of commerical service exports) in Turkey in 2005 to that in 2010?
Make the answer very short. 1.22. What is the ratio of the Cost of computers, communications and other services (% of commerical service exports) in Antigua and Barbuda in 2005 to that in 2011?
Give a very brief answer. 1.52. What is the ratio of the Cost of computers, communications and other services (% of commerical service exports) of Lebanon in 2005 to that in 2011?
Your answer should be compact. 0.81. What is the ratio of the Cost of computers, communications and other services (% of commerical service exports) of Turkey in 2005 to that in 2011?
Provide a succinct answer. 1.15. What is the ratio of the Cost of computers, communications and other services (% of commerical service exports) of Antigua and Barbuda in 2005 to that in 2012?
Make the answer very short. 1.53. What is the ratio of the Cost of computers, communications and other services (% of commerical service exports) in Lebanon in 2005 to that in 2012?
Give a very brief answer. 1.33. What is the ratio of the Cost of computers, communications and other services (% of commerical service exports) in Turkey in 2005 to that in 2012?
Ensure brevity in your answer.  1.16. What is the ratio of the Cost of computers, communications and other services (% of commerical service exports) in Antigua and Barbuda in 2006 to that in 2007?
Provide a short and direct response. 0.79. What is the ratio of the Cost of computers, communications and other services (% of commerical service exports) of Lebanon in 2006 to that in 2007?
Give a very brief answer. 0.98. What is the ratio of the Cost of computers, communications and other services (% of commerical service exports) of Turkey in 2006 to that in 2007?
Your response must be concise. 1.1. What is the ratio of the Cost of computers, communications and other services (% of commerical service exports) in Antigua and Barbuda in 2006 to that in 2008?
Provide a succinct answer. 0.89. What is the ratio of the Cost of computers, communications and other services (% of commerical service exports) in Lebanon in 2006 to that in 2008?
Offer a very short reply. 0.81. What is the ratio of the Cost of computers, communications and other services (% of commerical service exports) of Turkey in 2006 to that in 2008?
Provide a short and direct response. 1.06. What is the ratio of the Cost of computers, communications and other services (% of commerical service exports) in Antigua and Barbuda in 2006 to that in 2009?
Give a very brief answer. 1.18. What is the ratio of the Cost of computers, communications and other services (% of commerical service exports) of Lebanon in 2006 to that in 2009?
Make the answer very short. 0.91. What is the ratio of the Cost of computers, communications and other services (% of commerical service exports) in Turkey in 2006 to that in 2009?
Give a very brief answer. 1.18. What is the ratio of the Cost of computers, communications and other services (% of commerical service exports) of Antigua and Barbuda in 2006 to that in 2010?
Provide a succinct answer. 1.47. What is the ratio of the Cost of computers, communications and other services (% of commerical service exports) in Lebanon in 2006 to that in 2010?
Make the answer very short. 1.54. What is the ratio of the Cost of computers, communications and other services (% of commerical service exports) of Turkey in 2006 to that in 2010?
Your answer should be very brief. 1.26. What is the ratio of the Cost of computers, communications and other services (% of commerical service exports) of Antigua and Barbuda in 2006 to that in 2011?
Keep it short and to the point. 1.48. What is the ratio of the Cost of computers, communications and other services (% of commerical service exports) of Lebanon in 2006 to that in 2011?
Your answer should be compact. 0.97. What is the ratio of the Cost of computers, communications and other services (% of commerical service exports) in Turkey in 2006 to that in 2011?
Provide a short and direct response. 1.19. What is the ratio of the Cost of computers, communications and other services (% of commerical service exports) of Antigua and Barbuda in 2006 to that in 2012?
Your response must be concise. 1.49. What is the ratio of the Cost of computers, communications and other services (% of commerical service exports) of Lebanon in 2006 to that in 2012?
Your answer should be very brief. 1.58. What is the ratio of the Cost of computers, communications and other services (% of commerical service exports) of Turkey in 2006 to that in 2012?
Make the answer very short. 1.2. What is the ratio of the Cost of computers, communications and other services (% of commerical service exports) in Antigua and Barbuda in 2007 to that in 2008?
Offer a very short reply. 1.14. What is the ratio of the Cost of computers, communications and other services (% of commerical service exports) in Lebanon in 2007 to that in 2008?
Give a very brief answer. 0.83. What is the ratio of the Cost of computers, communications and other services (% of commerical service exports) of Turkey in 2007 to that in 2008?
Offer a terse response. 0.96. What is the ratio of the Cost of computers, communications and other services (% of commerical service exports) in Antigua and Barbuda in 2007 to that in 2009?
Your answer should be compact. 1.5. What is the ratio of the Cost of computers, communications and other services (% of commerical service exports) in Lebanon in 2007 to that in 2009?
Provide a succinct answer. 0.93. What is the ratio of the Cost of computers, communications and other services (% of commerical service exports) of Turkey in 2007 to that in 2009?
Offer a very short reply. 1.07. What is the ratio of the Cost of computers, communications and other services (% of commerical service exports) in Antigua and Barbuda in 2007 to that in 2010?
Give a very brief answer. 1.87. What is the ratio of the Cost of computers, communications and other services (% of commerical service exports) of Lebanon in 2007 to that in 2010?
Your answer should be very brief. 1.58. What is the ratio of the Cost of computers, communications and other services (% of commerical service exports) in Antigua and Barbuda in 2007 to that in 2011?
Offer a very short reply. 1.89. What is the ratio of the Cost of computers, communications and other services (% of commerical service exports) in Lebanon in 2007 to that in 2011?
Your answer should be very brief. 0.99. What is the ratio of the Cost of computers, communications and other services (% of commerical service exports) of Turkey in 2007 to that in 2011?
Your response must be concise. 1.08. What is the ratio of the Cost of computers, communications and other services (% of commerical service exports) of Antigua and Barbuda in 2007 to that in 2012?
Your answer should be compact. 1.9. What is the ratio of the Cost of computers, communications and other services (% of commerical service exports) of Lebanon in 2007 to that in 2012?
Offer a very short reply. 1.62. What is the ratio of the Cost of computers, communications and other services (% of commerical service exports) in Turkey in 2007 to that in 2012?
Your answer should be very brief. 1.09. What is the ratio of the Cost of computers, communications and other services (% of commerical service exports) of Antigua and Barbuda in 2008 to that in 2009?
Your answer should be very brief. 1.32. What is the ratio of the Cost of computers, communications and other services (% of commerical service exports) of Lebanon in 2008 to that in 2009?
Provide a short and direct response. 1.12. What is the ratio of the Cost of computers, communications and other services (% of commerical service exports) of Turkey in 2008 to that in 2009?
Provide a short and direct response. 1.11. What is the ratio of the Cost of computers, communications and other services (% of commerical service exports) of Antigua and Barbuda in 2008 to that in 2010?
Ensure brevity in your answer.  1.65. What is the ratio of the Cost of computers, communications and other services (% of commerical service exports) of Lebanon in 2008 to that in 2010?
Your response must be concise. 1.89. What is the ratio of the Cost of computers, communications and other services (% of commerical service exports) of Turkey in 2008 to that in 2010?
Keep it short and to the point. 1.19. What is the ratio of the Cost of computers, communications and other services (% of commerical service exports) of Antigua and Barbuda in 2008 to that in 2011?
Offer a very short reply. 1.66. What is the ratio of the Cost of computers, communications and other services (% of commerical service exports) in Lebanon in 2008 to that in 2011?
Your response must be concise. 1.19. What is the ratio of the Cost of computers, communications and other services (% of commerical service exports) of Turkey in 2008 to that in 2011?
Offer a very short reply. 1.12. What is the ratio of the Cost of computers, communications and other services (% of commerical service exports) in Antigua and Barbuda in 2008 to that in 2012?
Provide a succinct answer. 1.67. What is the ratio of the Cost of computers, communications and other services (% of commerical service exports) in Lebanon in 2008 to that in 2012?
Give a very brief answer. 1.95. What is the ratio of the Cost of computers, communications and other services (% of commerical service exports) in Turkey in 2008 to that in 2012?
Offer a terse response. 1.14. What is the ratio of the Cost of computers, communications and other services (% of commerical service exports) of Antigua and Barbuda in 2009 to that in 2010?
Your answer should be very brief. 1.25. What is the ratio of the Cost of computers, communications and other services (% of commerical service exports) of Lebanon in 2009 to that in 2010?
Give a very brief answer. 1.69. What is the ratio of the Cost of computers, communications and other services (% of commerical service exports) in Turkey in 2009 to that in 2010?
Ensure brevity in your answer.  1.07. What is the ratio of the Cost of computers, communications and other services (% of commerical service exports) of Antigua and Barbuda in 2009 to that in 2011?
Provide a succinct answer. 1.26. What is the ratio of the Cost of computers, communications and other services (% of commerical service exports) in Lebanon in 2009 to that in 2011?
Your answer should be very brief. 1.06. What is the ratio of the Cost of computers, communications and other services (% of commerical service exports) of Antigua and Barbuda in 2009 to that in 2012?
Offer a terse response. 1.27. What is the ratio of the Cost of computers, communications and other services (% of commerical service exports) in Lebanon in 2009 to that in 2012?
Offer a very short reply. 1.74. What is the ratio of the Cost of computers, communications and other services (% of commerical service exports) of Turkey in 2009 to that in 2012?
Offer a terse response. 1.02. What is the ratio of the Cost of computers, communications and other services (% of commerical service exports) of Antigua and Barbuda in 2010 to that in 2011?
Provide a succinct answer. 1.01. What is the ratio of the Cost of computers, communications and other services (% of commerical service exports) of Lebanon in 2010 to that in 2011?
Offer a very short reply. 0.63. What is the ratio of the Cost of computers, communications and other services (% of commerical service exports) in Turkey in 2010 to that in 2011?
Offer a terse response. 0.94. What is the ratio of the Cost of computers, communications and other services (% of commerical service exports) in Antigua and Barbuda in 2010 to that in 2012?
Offer a terse response. 1.02. What is the ratio of the Cost of computers, communications and other services (% of commerical service exports) of Lebanon in 2010 to that in 2012?
Offer a very short reply. 1.03. What is the ratio of the Cost of computers, communications and other services (% of commerical service exports) of Turkey in 2010 to that in 2012?
Provide a succinct answer. 0.96. What is the ratio of the Cost of computers, communications and other services (% of commerical service exports) in Antigua and Barbuda in 2011 to that in 2012?
Give a very brief answer. 1.01. What is the ratio of the Cost of computers, communications and other services (% of commerical service exports) in Lebanon in 2011 to that in 2012?
Offer a terse response. 1.64. What is the ratio of the Cost of computers, communications and other services (% of commerical service exports) of Turkey in 2011 to that in 2012?
Keep it short and to the point. 1.01. What is the difference between the highest and the second highest Cost of computers, communications and other services (% of commerical service exports) in Antigua and Barbuda?
Your answer should be compact. 1.46. What is the difference between the highest and the second highest Cost of computers, communications and other services (% of commerical service exports) of Lebanon?
Keep it short and to the point. 6.54. What is the difference between the highest and the second highest Cost of computers, communications and other services (% of commerical service exports) of Turkey?
Your answer should be compact. 0.32. What is the difference between the highest and the lowest Cost of computers, communications and other services (% of commerical service exports) in Antigua and Barbuda?
Your answer should be compact. 5.78. What is the difference between the highest and the lowest Cost of computers, communications and other services (% of commerical service exports) of Lebanon?
Your answer should be compact. 30.16. What is the difference between the highest and the lowest Cost of computers, communications and other services (% of commerical service exports) in Turkey?
Your answer should be very brief. 1.99. 